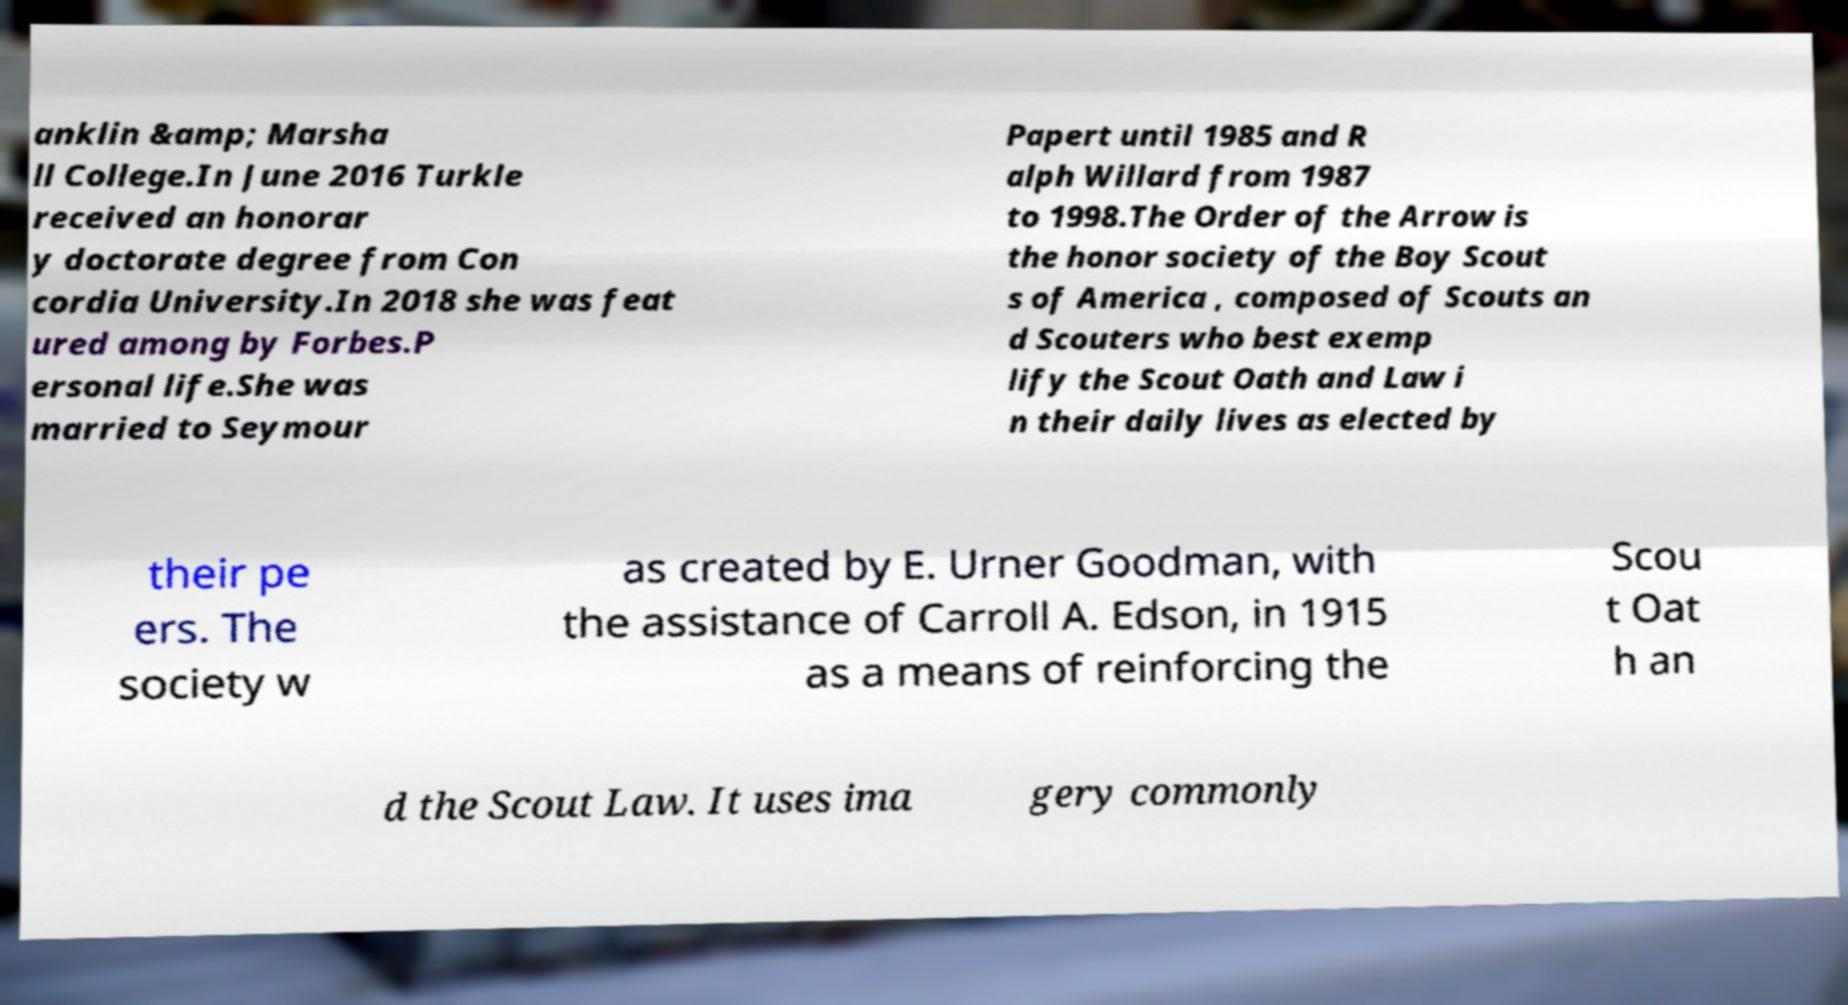Could you extract and type out the text from this image? anklin &amp; Marsha ll College.In June 2016 Turkle received an honorar y doctorate degree from Con cordia University.In 2018 she was feat ured among by Forbes.P ersonal life.She was married to Seymour Papert until 1985 and R alph Willard from 1987 to 1998.The Order of the Arrow is the honor society of the Boy Scout s of America , composed of Scouts an d Scouters who best exemp lify the Scout Oath and Law i n their daily lives as elected by their pe ers. The society w as created by E. Urner Goodman, with the assistance of Carroll A. Edson, in 1915 as a means of reinforcing the Scou t Oat h an d the Scout Law. It uses ima gery commonly 